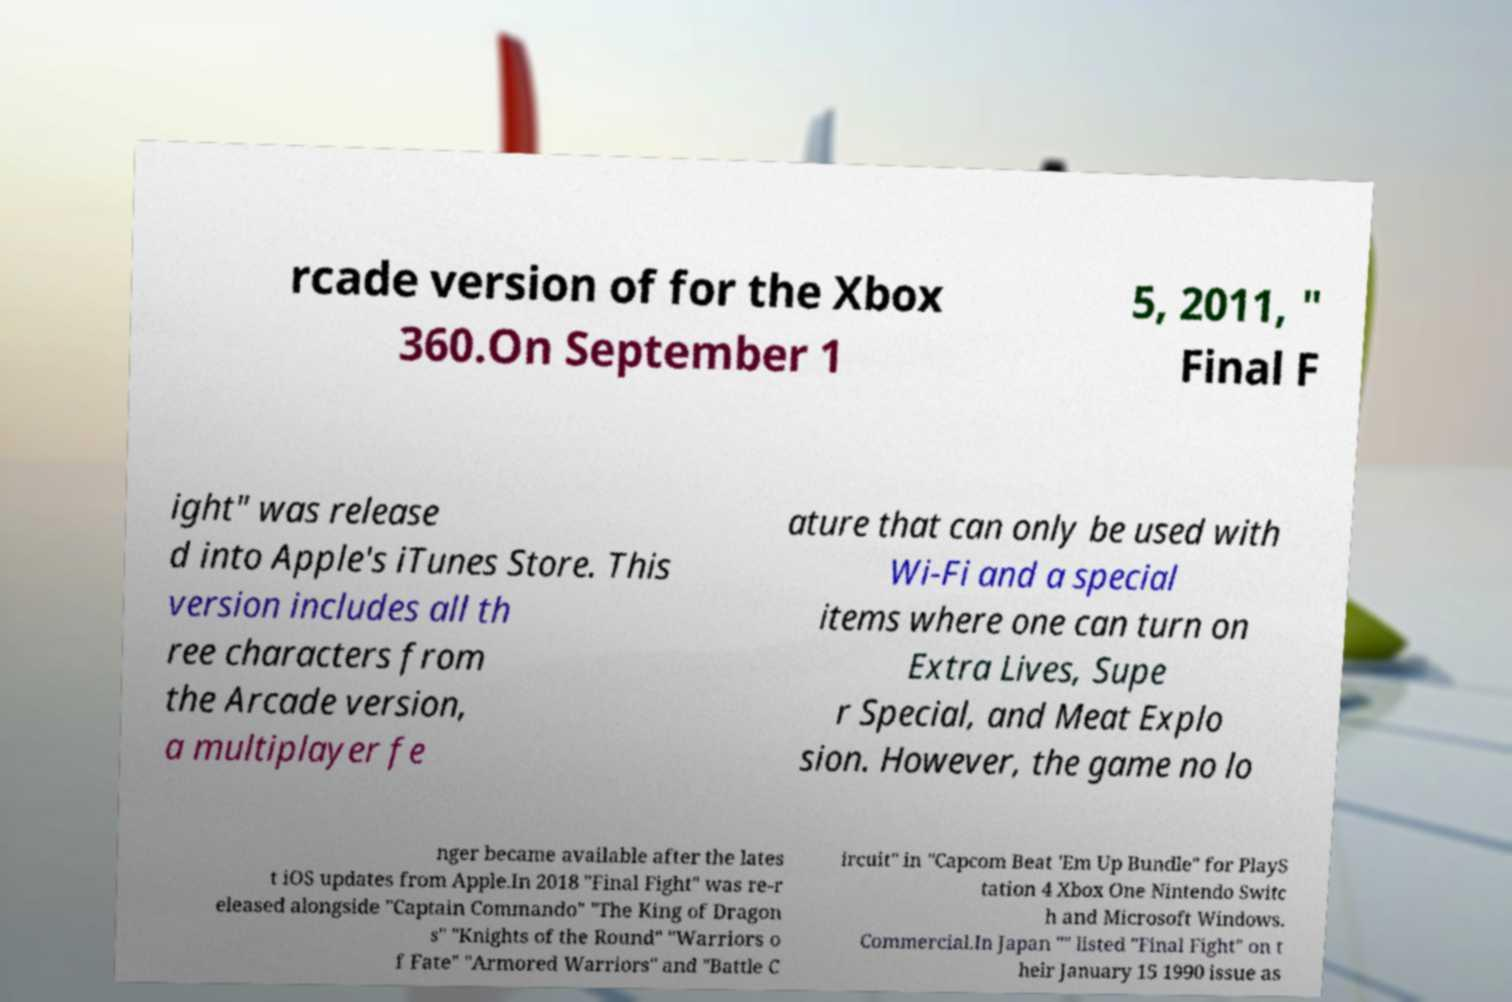Please read and relay the text visible in this image. What does it say? rcade version of for the Xbox 360.On September 1 5, 2011, " Final F ight" was release d into Apple's iTunes Store. This version includes all th ree characters from the Arcade version, a multiplayer fe ature that can only be used with Wi-Fi and a special items where one can turn on Extra Lives, Supe r Special, and Meat Explo sion. However, the game no lo nger became available after the lates t iOS updates from Apple.In 2018 "Final Fight" was re-r eleased alongside "Captain Commando" "The King of Dragon s" "Knights of the Round" "Warriors o f Fate" "Armored Warriors" and "Battle C ircuit" in "Capcom Beat 'Em Up Bundle" for PlayS tation 4 Xbox One Nintendo Switc h and Microsoft Windows. Commercial.In Japan "" listed "Final Fight" on t heir January 15 1990 issue as 